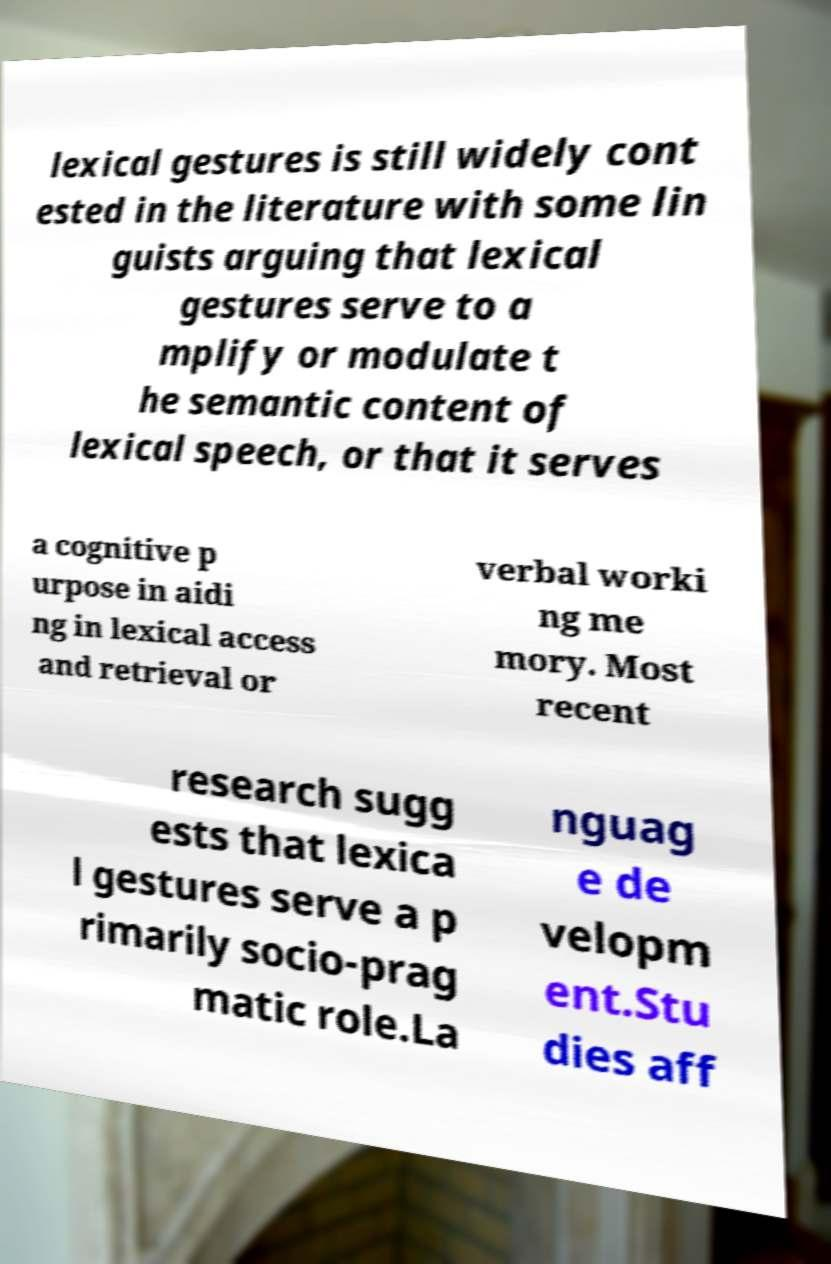For documentation purposes, I need the text within this image transcribed. Could you provide that? lexical gestures is still widely cont ested in the literature with some lin guists arguing that lexical gestures serve to a mplify or modulate t he semantic content of lexical speech, or that it serves a cognitive p urpose in aidi ng in lexical access and retrieval or verbal worki ng me mory. Most recent research sugg ests that lexica l gestures serve a p rimarily socio-prag matic role.La nguag e de velopm ent.Stu dies aff 